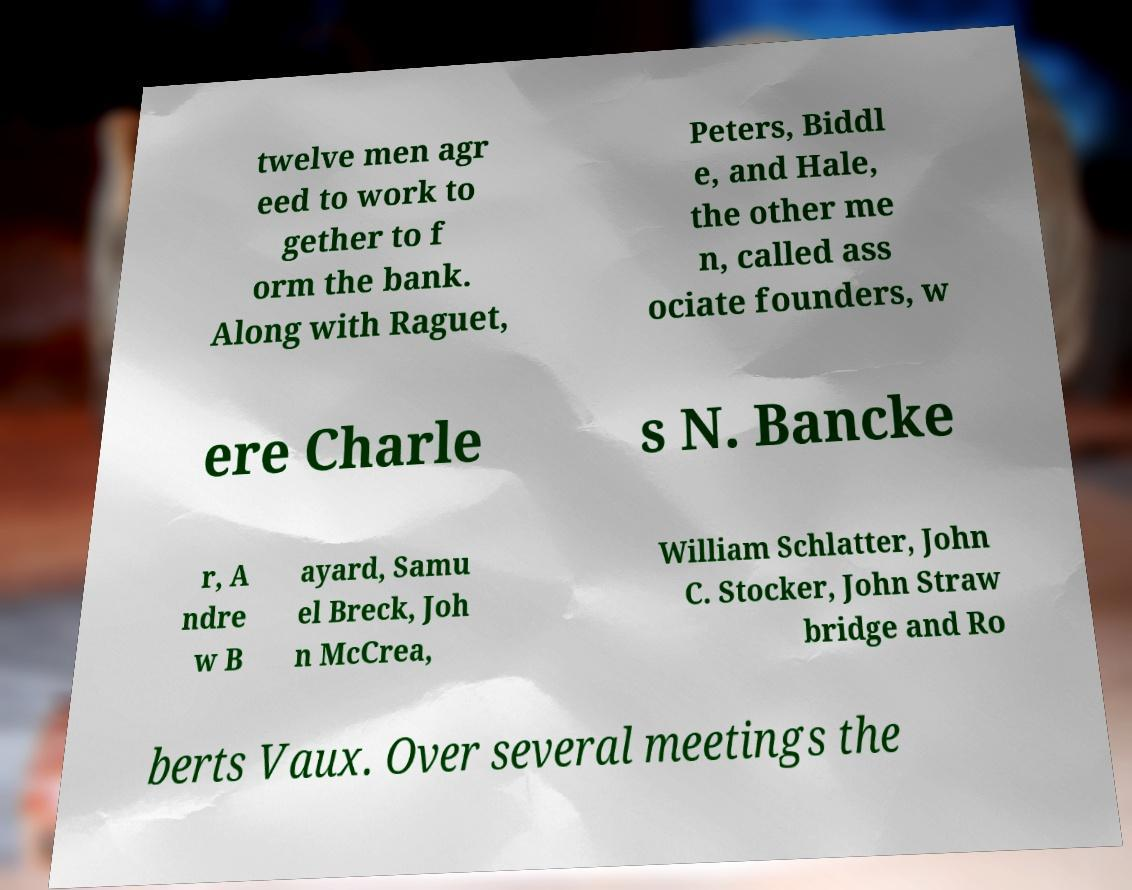Please identify and transcribe the text found in this image. twelve men agr eed to work to gether to f orm the bank. Along with Raguet, Peters, Biddl e, and Hale, the other me n, called ass ociate founders, w ere Charle s N. Bancke r, A ndre w B ayard, Samu el Breck, Joh n McCrea, William Schlatter, John C. Stocker, John Straw bridge and Ro berts Vaux. Over several meetings the 